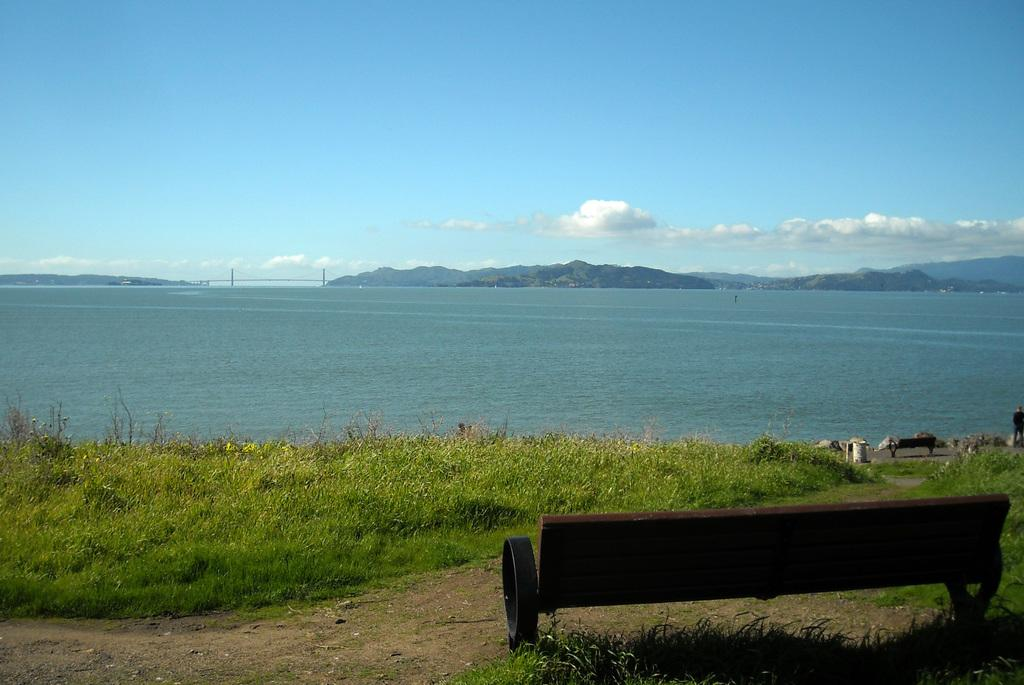What type of natural environment is depicted in the image? The image contains water, grass, plants, and hills, which suggests a natural environment. What type of man-made structures are present in the image? There are benches, a walkway, and a bridge in the image. What is the primary surface for walking or sitting in the image? The walkway and benches serve as surfaces for walking or sitting. What is visible in the background of the image? The background of the image includes hills and the sky. What type of card is being used to feed the squirrel in the image? There is no card or squirrel present in the image. What type of juice is being served on the bridge in the image? There is no juice or serving activity depicted on the bridge in the image. 